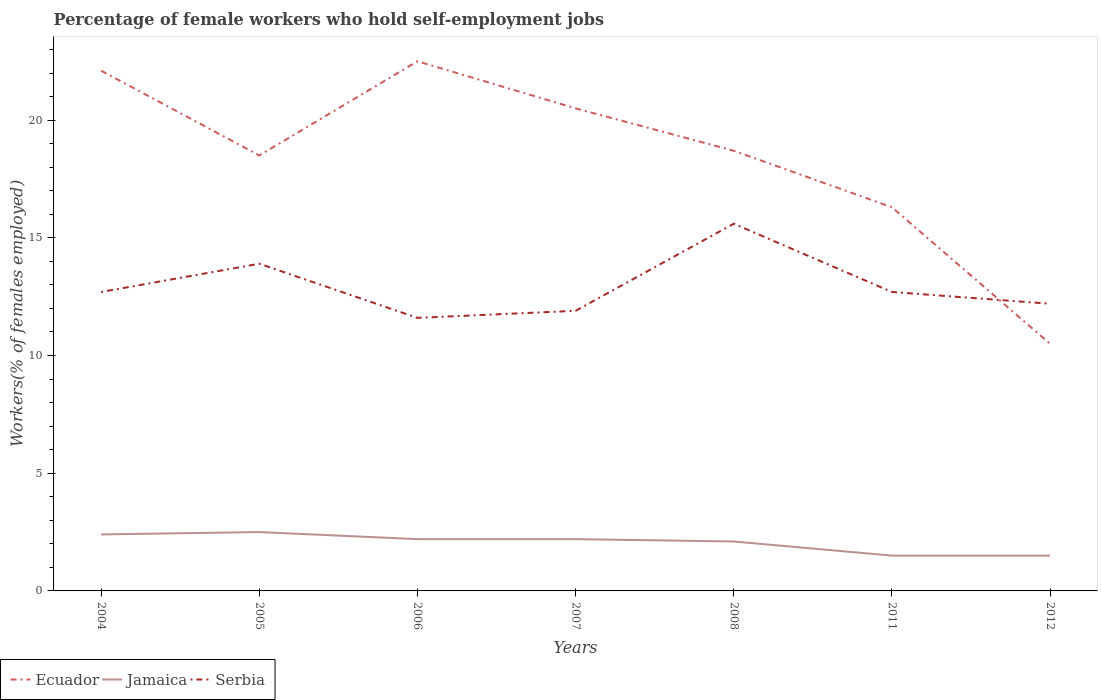What is the total percentage of self-employed female workers in Serbia in the graph?
Ensure brevity in your answer.  0. Is the percentage of self-employed female workers in Serbia strictly greater than the percentage of self-employed female workers in Ecuador over the years?
Offer a very short reply. No. Does the graph contain any zero values?
Your answer should be very brief. No. Where does the legend appear in the graph?
Offer a terse response. Bottom left. How many legend labels are there?
Provide a succinct answer. 3. How are the legend labels stacked?
Your response must be concise. Horizontal. What is the title of the graph?
Provide a succinct answer. Percentage of female workers who hold self-employment jobs. What is the label or title of the Y-axis?
Ensure brevity in your answer.  Workers(% of females employed). What is the Workers(% of females employed) of Ecuador in 2004?
Provide a short and direct response. 22.1. What is the Workers(% of females employed) in Jamaica in 2004?
Provide a succinct answer. 2.4. What is the Workers(% of females employed) of Serbia in 2004?
Ensure brevity in your answer.  12.7. What is the Workers(% of females employed) of Jamaica in 2005?
Your response must be concise. 2.5. What is the Workers(% of females employed) of Serbia in 2005?
Offer a very short reply. 13.9. What is the Workers(% of females employed) in Ecuador in 2006?
Make the answer very short. 22.5. What is the Workers(% of females employed) of Jamaica in 2006?
Keep it short and to the point. 2.2. What is the Workers(% of females employed) of Serbia in 2006?
Your response must be concise. 11.6. What is the Workers(% of females employed) of Ecuador in 2007?
Offer a terse response. 20.5. What is the Workers(% of females employed) in Jamaica in 2007?
Your response must be concise. 2.2. What is the Workers(% of females employed) in Serbia in 2007?
Offer a very short reply. 11.9. What is the Workers(% of females employed) of Ecuador in 2008?
Give a very brief answer. 18.7. What is the Workers(% of females employed) of Jamaica in 2008?
Provide a short and direct response. 2.1. What is the Workers(% of females employed) of Serbia in 2008?
Your answer should be compact. 15.6. What is the Workers(% of females employed) in Ecuador in 2011?
Make the answer very short. 16.3. What is the Workers(% of females employed) in Jamaica in 2011?
Keep it short and to the point. 1.5. What is the Workers(% of females employed) in Serbia in 2011?
Make the answer very short. 12.7. What is the Workers(% of females employed) of Ecuador in 2012?
Your response must be concise. 10.5. What is the Workers(% of females employed) of Jamaica in 2012?
Keep it short and to the point. 1.5. What is the Workers(% of females employed) in Serbia in 2012?
Ensure brevity in your answer.  12.2. Across all years, what is the maximum Workers(% of females employed) in Serbia?
Keep it short and to the point. 15.6. Across all years, what is the minimum Workers(% of females employed) of Ecuador?
Give a very brief answer. 10.5. Across all years, what is the minimum Workers(% of females employed) in Serbia?
Give a very brief answer. 11.6. What is the total Workers(% of females employed) of Ecuador in the graph?
Your response must be concise. 129.1. What is the total Workers(% of females employed) of Serbia in the graph?
Keep it short and to the point. 90.6. What is the difference between the Workers(% of females employed) in Ecuador in 2004 and that in 2005?
Give a very brief answer. 3.6. What is the difference between the Workers(% of females employed) in Serbia in 2004 and that in 2005?
Your answer should be compact. -1.2. What is the difference between the Workers(% of females employed) in Ecuador in 2004 and that in 2006?
Offer a terse response. -0.4. What is the difference between the Workers(% of females employed) in Serbia in 2004 and that in 2006?
Provide a short and direct response. 1.1. What is the difference between the Workers(% of females employed) of Jamaica in 2004 and that in 2007?
Offer a very short reply. 0.2. What is the difference between the Workers(% of females employed) of Serbia in 2004 and that in 2007?
Provide a short and direct response. 0.8. What is the difference between the Workers(% of females employed) of Ecuador in 2004 and that in 2008?
Provide a short and direct response. 3.4. What is the difference between the Workers(% of females employed) of Jamaica in 2004 and that in 2008?
Provide a short and direct response. 0.3. What is the difference between the Workers(% of females employed) of Serbia in 2004 and that in 2008?
Keep it short and to the point. -2.9. What is the difference between the Workers(% of females employed) of Serbia in 2004 and that in 2011?
Keep it short and to the point. 0. What is the difference between the Workers(% of females employed) in Ecuador in 2004 and that in 2012?
Provide a succinct answer. 11.6. What is the difference between the Workers(% of females employed) in Jamaica in 2004 and that in 2012?
Your response must be concise. 0.9. What is the difference between the Workers(% of females employed) in Ecuador in 2005 and that in 2006?
Ensure brevity in your answer.  -4. What is the difference between the Workers(% of females employed) of Ecuador in 2005 and that in 2007?
Your answer should be compact. -2. What is the difference between the Workers(% of females employed) of Jamaica in 2005 and that in 2007?
Your answer should be very brief. 0.3. What is the difference between the Workers(% of females employed) of Serbia in 2005 and that in 2007?
Provide a short and direct response. 2. What is the difference between the Workers(% of females employed) in Serbia in 2005 and that in 2012?
Offer a very short reply. 1.7. What is the difference between the Workers(% of females employed) of Ecuador in 2006 and that in 2007?
Your response must be concise. 2. What is the difference between the Workers(% of females employed) of Ecuador in 2006 and that in 2008?
Offer a terse response. 3.8. What is the difference between the Workers(% of females employed) of Ecuador in 2006 and that in 2011?
Give a very brief answer. 6.2. What is the difference between the Workers(% of females employed) of Ecuador in 2006 and that in 2012?
Your answer should be very brief. 12. What is the difference between the Workers(% of females employed) of Serbia in 2006 and that in 2012?
Ensure brevity in your answer.  -0.6. What is the difference between the Workers(% of females employed) in Ecuador in 2007 and that in 2011?
Keep it short and to the point. 4.2. What is the difference between the Workers(% of females employed) of Jamaica in 2007 and that in 2011?
Your answer should be very brief. 0.7. What is the difference between the Workers(% of females employed) of Ecuador in 2007 and that in 2012?
Your answer should be compact. 10. What is the difference between the Workers(% of females employed) in Jamaica in 2007 and that in 2012?
Provide a succinct answer. 0.7. What is the difference between the Workers(% of females employed) in Serbia in 2007 and that in 2012?
Keep it short and to the point. -0.3. What is the difference between the Workers(% of females employed) in Serbia in 2008 and that in 2011?
Your response must be concise. 2.9. What is the difference between the Workers(% of females employed) in Jamaica in 2008 and that in 2012?
Your response must be concise. 0.6. What is the difference between the Workers(% of females employed) in Serbia in 2008 and that in 2012?
Provide a succinct answer. 3.4. What is the difference between the Workers(% of females employed) of Ecuador in 2011 and that in 2012?
Your answer should be compact. 5.8. What is the difference between the Workers(% of females employed) in Jamaica in 2011 and that in 2012?
Your answer should be compact. 0. What is the difference between the Workers(% of females employed) in Serbia in 2011 and that in 2012?
Give a very brief answer. 0.5. What is the difference between the Workers(% of females employed) in Ecuador in 2004 and the Workers(% of females employed) in Jamaica in 2005?
Your response must be concise. 19.6. What is the difference between the Workers(% of females employed) of Ecuador in 2004 and the Workers(% of females employed) of Serbia in 2005?
Provide a succinct answer. 8.2. What is the difference between the Workers(% of females employed) of Ecuador in 2004 and the Workers(% of females employed) of Jamaica in 2006?
Ensure brevity in your answer.  19.9. What is the difference between the Workers(% of females employed) in Jamaica in 2004 and the Workers(% of females employed) in Serbia in 2006?
Your answer should be compact. -9.2. What is the difference between the Workers(% of females employed) of Ecuador in 2004 and the Workers(% of females employed) of Jamaica in 2007?
Provide a short and direct response. 19.9. What is the difference between the Workers(% of females employed) in Ecuador in 2004 and the Workers(% of females employed) in Serbia in 2007?
Your response must be concise. 10.2. What is the difference between the Workers(% of females employed) in Ecuador in 2004 and the Workers(% of females employed) in Serbia in 2008?
Give a very brief answer. 6.5. What is the difference between the Workers(% of females employed) in Jamaica in 2004 and the Workers(% of females employed) in Serbia in 2008?
Ensure brevity in your answer.  -13.2. What is the difference between the Workers(% of females employed) in Ecuador in 2004 and the Workers(% of females employed) in Jamaica in 2011?
Provide a succinct answer. 20.6. What is the difference between the Workers(% of females employed) of Ecuador in 2004 and the Workers(% of females employed) of Serbia in 2011?
Your response must be concise. 9.4. What is the difference between the Workers(% of females employed) of Ecuador in 2004 and the Workers(% of females employed) of Jamaica in 2012?
Provide a short and direct response. 20.6. What is the difference between the Workers(% of females employed) of Ecuador in 2005 and the Workers(% of females employed) of Jamaica in 2006?
Make the answer very short. 16.3. What is the difference between the Workers(% of females employed) in Ecuador in 2005 and the Workers(% of females employed) in Serbia in 2006?
Your answer should be very brief. 6.9. What is the difference between the Workers(% of females employed) of Ecuador in 2005 and the Workers(% of females employed) of Jamaica in 2008?
Keep it short and to the point. 16.4. What is the difference between the Workers(% of females employed) in Jamaica in 2005 and the Workers(% of females employed) in Serbia in 2008?
Your answer should be compact. -13.1. What is the difference between the Workers(% of females employed) of Ecuador in 2005 and the Workers(% of females employed) of Jamaica in 2011?
Provide a short and direct response. 17. What is the difference between the Workers(% of females employed) of Jamaica in 2005 and the Workers(% of females employed) of Serbia in 2011?
Your response must be concise. -10.2. What is the difference between the Workers(% of females employed) of Ecuador in 2005 and the Workers(% of females employed) of Jamaica in 2012?
Make the answer very short. 17. What is the difference between the Workers(% of females employed) in Ecuador in 2006 and the Workers(% of females employed) in Jamaica in 2007?
Offer a very short reply. 20.3. What is the difference between the Workers(% of females employed) of Ecuador in 2006 and the Workers(% of females employed) of Serbia in 2007?
Your answer should be very brief. 10.6. What is the difference between the Workers(% of females employed) in Jamaica in 2006 and the Workers(% of females employed) in Serbia in 2007?
Provide a succinct answer. -9.7. What is the difference between the Workers(% of females employed) in Ecuador in 2006 and the Workers(% of females employed) in Jamaica in 2008?
Keep it short and to the point. 20.4. What is the difference between the Workers(% of females employed) in Jamaica in 2006 and the Workers(% of females employed) in Serbia in 2008?
Your answer should be compact. -13.4. What is the difference between the Workers(% of females employed) of Ecuador in 2006 and the Workers(% of females employed) of Jamaica in 2012?
Make the answer very short. 21. What is the difference between the Workers(% of females employed) of Ecuador in 2007 and the Workers(% of females employed) of Serbia in 2008?
Your answer should be very brief. 4.9. What is the difference between the Workers(% of females employed) of Jamaica in 2007 and the Workers(% of females employed) of Serbia in 2008?
Make the answer very short. -13.4. What is the difference between the Workers(% of females employed) in Ecuador in 2007 and the Workers(% of females employed) in Serbia in 2012?
Make the answer very short. 8.3. What is the difference between the Workers(% of females employed) of Ecuador in 2008 and the Workers(% of females employed) of Serbia in 2011?
Make the answer very short. 6. What is the difference between the Workers(% of females employed) in Ecuador in 2008 and the Workers(% of females employed) in Serbia in 2012?
Ensure brevity in your answer.  6.5. What is the difference between the Workers(% of females employed) in Ecuador in 2011 and the Workers(% of females employed) in Serbia in 2012?
Ensure brevity in your answer.  4.1. What is the difference between the Workers(% of females employed) of Jamaica in 2011 and the Workers(% of females employed) of Serbia in 2012?
Your response must be concise. -10.7. What is the average Workers(% of females employed) in Ecuador per year?
Keep it short and to the point. 18.44. What is the average Workers(% of females employed) of Jamaica per year?
Provide a succinct answer. 2.06. What is the average Workers(% of females employed) in Serbia per year?
Offer a very short reply. 12.94. In the year 2004, what is the difference between the Workers(% of females employed) in Ecuador and Workers(% of females employed) in Serbia?
Make the answer very short. 9.4. In the year 2006, what is the difference between the Workers(% of females employed) of Ecuador and Workers(% of females employed) of Jamaica?
Make the answer very short. 20.3. In the year 2006, what is the difference between the Workers(% of females employed) in Ecuador and Workers(% of females employed) in Serbia?
Ensure brevity in your answer.  10.9. In the year 2007, what is the difference between the Workers(% of females employed) in Ecuador and Workers(% of females employed) in Serbia?
Offer a terse response. 8.6. In the year 2011, what is the difference between the Workers(% of females employed) of Jamaica and Workers(% of females employed) of Serbia?
Provide a short and direct response. -11.2. In the year 2012, what is the difference between the Workers(% of females employed) in Ecuador and Workers(% of females employed) in Jamaica?
Offer a very short reply. 9. In the year 2012, what is the difference between the Workers(% of females employed) in Ecuador and Workers(% of females employed) in Serbia?
Your response must be concise. -1.7. In the year 2012, what is the difference between the Workers(% of females employed) of Jamaica and Workers(% of females employed) of Serbia?
Offer a very short reply. -10.7. What is the ratio of the Workers(% of females employed) of Ecuador in 2004 to that in 2005?
Offer a very short reply. 1.19. What is the ratio of the Workers(% of females employed) in Serbia in 2004 to that in 2005?
Give a very brief answer. 0.91. What is the ratio of the Workers(% of females employed) in Ecuador in 2004 to that in 2006?
Give a very brief answer. 0.98. What is the ratio of the Workers(% of females employed) of Jamaica in 2004 to that in 2006?
Give a very brief answer. 1.09. What is the ratio of the Workers(% of females employed) in Serbia in 2004 to that in 2006?
Ensure brevity in your answer.  1.09. What is the ratio of the Workers(% of females employed) in Ecuador in 2004 to that in 2007?
Provide a short and direct response. 1.08. What is the ratio of the Workers(% of females employed) of Jamaica in 2004 to that in 2007?
Your response must be concise. 1.09. What is the ratio of the Workers(% of females employed) of Serbia in 2004 to that in 2007?
Provide a succinct answer. 1.07. What is the ratio of the Workers(% of females employed) of Ecuador in 2004 to that in 2008?
Offer a terse response. 1.18. What is the ratio of the Workers(% of females employed) of Serbia in 2004 to that in 2008?
Make the answer very short. 0.81. What is the ratio of the Workers(% of females employed) of Ecuador in 2004 to that in 2011?
Offer a terse response. 1.36. What is the ratio of the Workers(% of females employed) in Jamaica in 2004 to that in 2011?
Keep it short and to the point. 1.6. What is the ratio of the Workers(% of females employed) in Ecuador in 2004 to that in 2012?
Ensure brevity in your answer.  2.1. What is the ratio of the Workers(% of females employed) of Jamaica in 2004 to that in 2012?
Make the answer very short. 1.6. What is the ratio of the Workers(% of females employed) of Serbia in 2004 to that in 2012?
Your answer should be very brief. 1.04. What is the ratio of the Workers(% of females employed) in Ecuador in 2005 to that in 2006?
Make the answer very short. 0.82. What is the ratio of the Workers(% of females employed) of Jamaica in 2005 to that in 2006?
Offer a very short reply. 1.14. What is the ratio of the Workers(% of females employed) in Serbia in 2005 to that in 2006?
Your answer should be compact. 1.2. What is the ratio of the Workers(% of females employed) in Ecuador in 2005 to that in 2007?
Your answer should be very brief. 0.9. What is the ratio of the Workers(% of females employed) of Jamaica in 2005 to that in 2007?
Provide a succinct answer. 1.14. What is the ratio of the Workers(% of females employed) of Serbia in 2005 to that in 2007?
Your answer should be very brief. 1.17. What is the ratio of the Workers(% of females employed) of Ecuador in 2005 to that in 2008?
Your answer should be very brief. 0.99. What is the ratio of the Workers(% of females employed) in Jamaica in 2005 to that in 2008?
Make the answer very short. 1.19. What is the ratio of the Workers(% of females employed) in Serbia in 2005 to that in 2008?
Your answer should be compact. 0.89. What is the ratio of the Workers(% of females employed) in Ecuador in 2005 to that in 2011?
Your answer should be compact. 1.14. What is the ratio of the Workers(% of females employed) in Jamaica in 2005 to that in 2011?
Give a very brief answer. 1.67. What is the ratio of the Workers(% of females employed) of Serbia in 2005 to that in 2011?
Your response must be concise. 1.09. What is the ratio of the Workers(% of females employed) of Ecuador in 2005 to that in 2012?
Offer a very short reply. 1.76. What is the ratio of the Workers(% of females employed) of Serbia in 2005 to that in 2012?
Provide a succinct answer. 1.14. What is the ratio of the Workers(% of females employed) of Ecuador in 2006 to that in 2007?
Keep it short and to the point. 1.1. What is the ratio of the Workers(% of females employed) in Serbia in 2006 to that in 2007?
Your answer should be very brief. 0.97. What is the ratio of the Workers(% of females employed) in Ecuador in 2006 to that in 2008?
Ensure brevity in your answer.  1.2. What is the ratio of the Workers(% of females employed) in Jamaica in 2006 to that in 2008?
Your response must be concise. 1.05. What is the ratio of the Workers(% of females employed) of Serbia in 2006 to that in 2008?
Make the answer very short. 0.74. What is the ratio of the Workers(% of females employed) in Ecuador in 2006 to that in 2011?
Offer a very short reply. 1.38. What is the ratio of the Workers(% of females employed) in Jamaica in 2006 to that in 2011?
Offer a very short reply. 1.47. What is the ratio of the Workers(% of females employed) of Serbia in 2006 to that in 2011?
Offer a very short reply. 0.91. What is the ratio of the Workers(% of females employed) in Ecuador in 2006 to that in 2012?
Make the answer very short. 2.14. What is the ratio of the Workers(% of females employed) in Jamaica in 2006 to that in 2012?
Ensure brevity in your answer.  1.47. What is the ratio of the Workers(% of females employed) of Serbia in 2006 to that in 2012?
Give a very brief answer. 0.95. What is the ratio of the Workers(% of females employed) in Ecuador in 2007 to that in 2008?
Offer a terse response. 1.1. What is the ratio of the Workers(% of females employed) of Jamaica in 2007 to that in 2008?
Make the answer very short. 1.05. What is the ratio of the Workers(% of females employed) in Serbia in 2007 to that in 2008?
Your answer should be compact. 0.76. What is the ratio of the Workers(% of females employed) of Ecuador in 2007 to that in 2011?
Provide a succinct answer. 1.26. What is the ratio of the Workers(% of females employed) of Jamaica in 2007 to that in 2011?
Offer a very short reply. 1.47. What is the ratio of the Workers(% of females employed) of Serbia in 2007 to that in 2011?
Give a very brief answer. 0.94. What is the ratio of the Workers(% of females employed) in Ecuador in 2007 to that in 2012?
Keep it short and to the point. 1.95. What is the ratio of the Workers(% of females employed) of Jamaica in 2007 to that in 2012?
Give a very brief answer. 1.47. What is the ratio of the Workers(% of females employed) of Serbia in 2007 to that in 2012?
Make the answer very short. 0.98. What is the ratio of the Workers(% of females employed) of Ecuador in 2008 to that in 2011?
Make the answer very short. 1.15. What is the ratio of the Workers(% of females employed) in Serbia in 2008 to that in 2011?
Your response must be concise. 1.23. What is the ratio of the Workers(% of females employed) in Ecuador in 2008 to that in 2012?
Your answer should be very brief. 1.78. What is the ratio of the Workers(% of females employed) of Serbia in 2008 to that in 2012?
Your answer should be compact. 1.28. What is the ratio of the Workers(% of females employed) in Ecuador in 2011 to that in 2012?
Provide a succinct answer. 1.55. What is the ratio of the Workers(% of females employed) of Serbia in 2011 to that in 2012?
Your response must be concise. 1.04. What is the difference between the highest and the second highest Workers(% of females employed) in Jamaica?
Give a very brief answer. 0.1. What is the difference between the highest and the second highest Workers(% of females employed) of Serbia?
Ensure brevity in your answer.  1.7. What is the difference between the highest and the lowest Workers(% of females employed) of Jamaica?
Give a very brief answer. 1. 